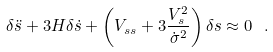<formula> <loc_0><loc_0><loc_500><loc_500>\delta \ddot { s } + 3 H \delta \dot { s } + \left ( V _ { s s } + 3 \frac { V _ { s } ^ { 2 } } { \dot { \sigma } ^ { 2 } } \right ) \delta s \approx 0 \ .</formula> 